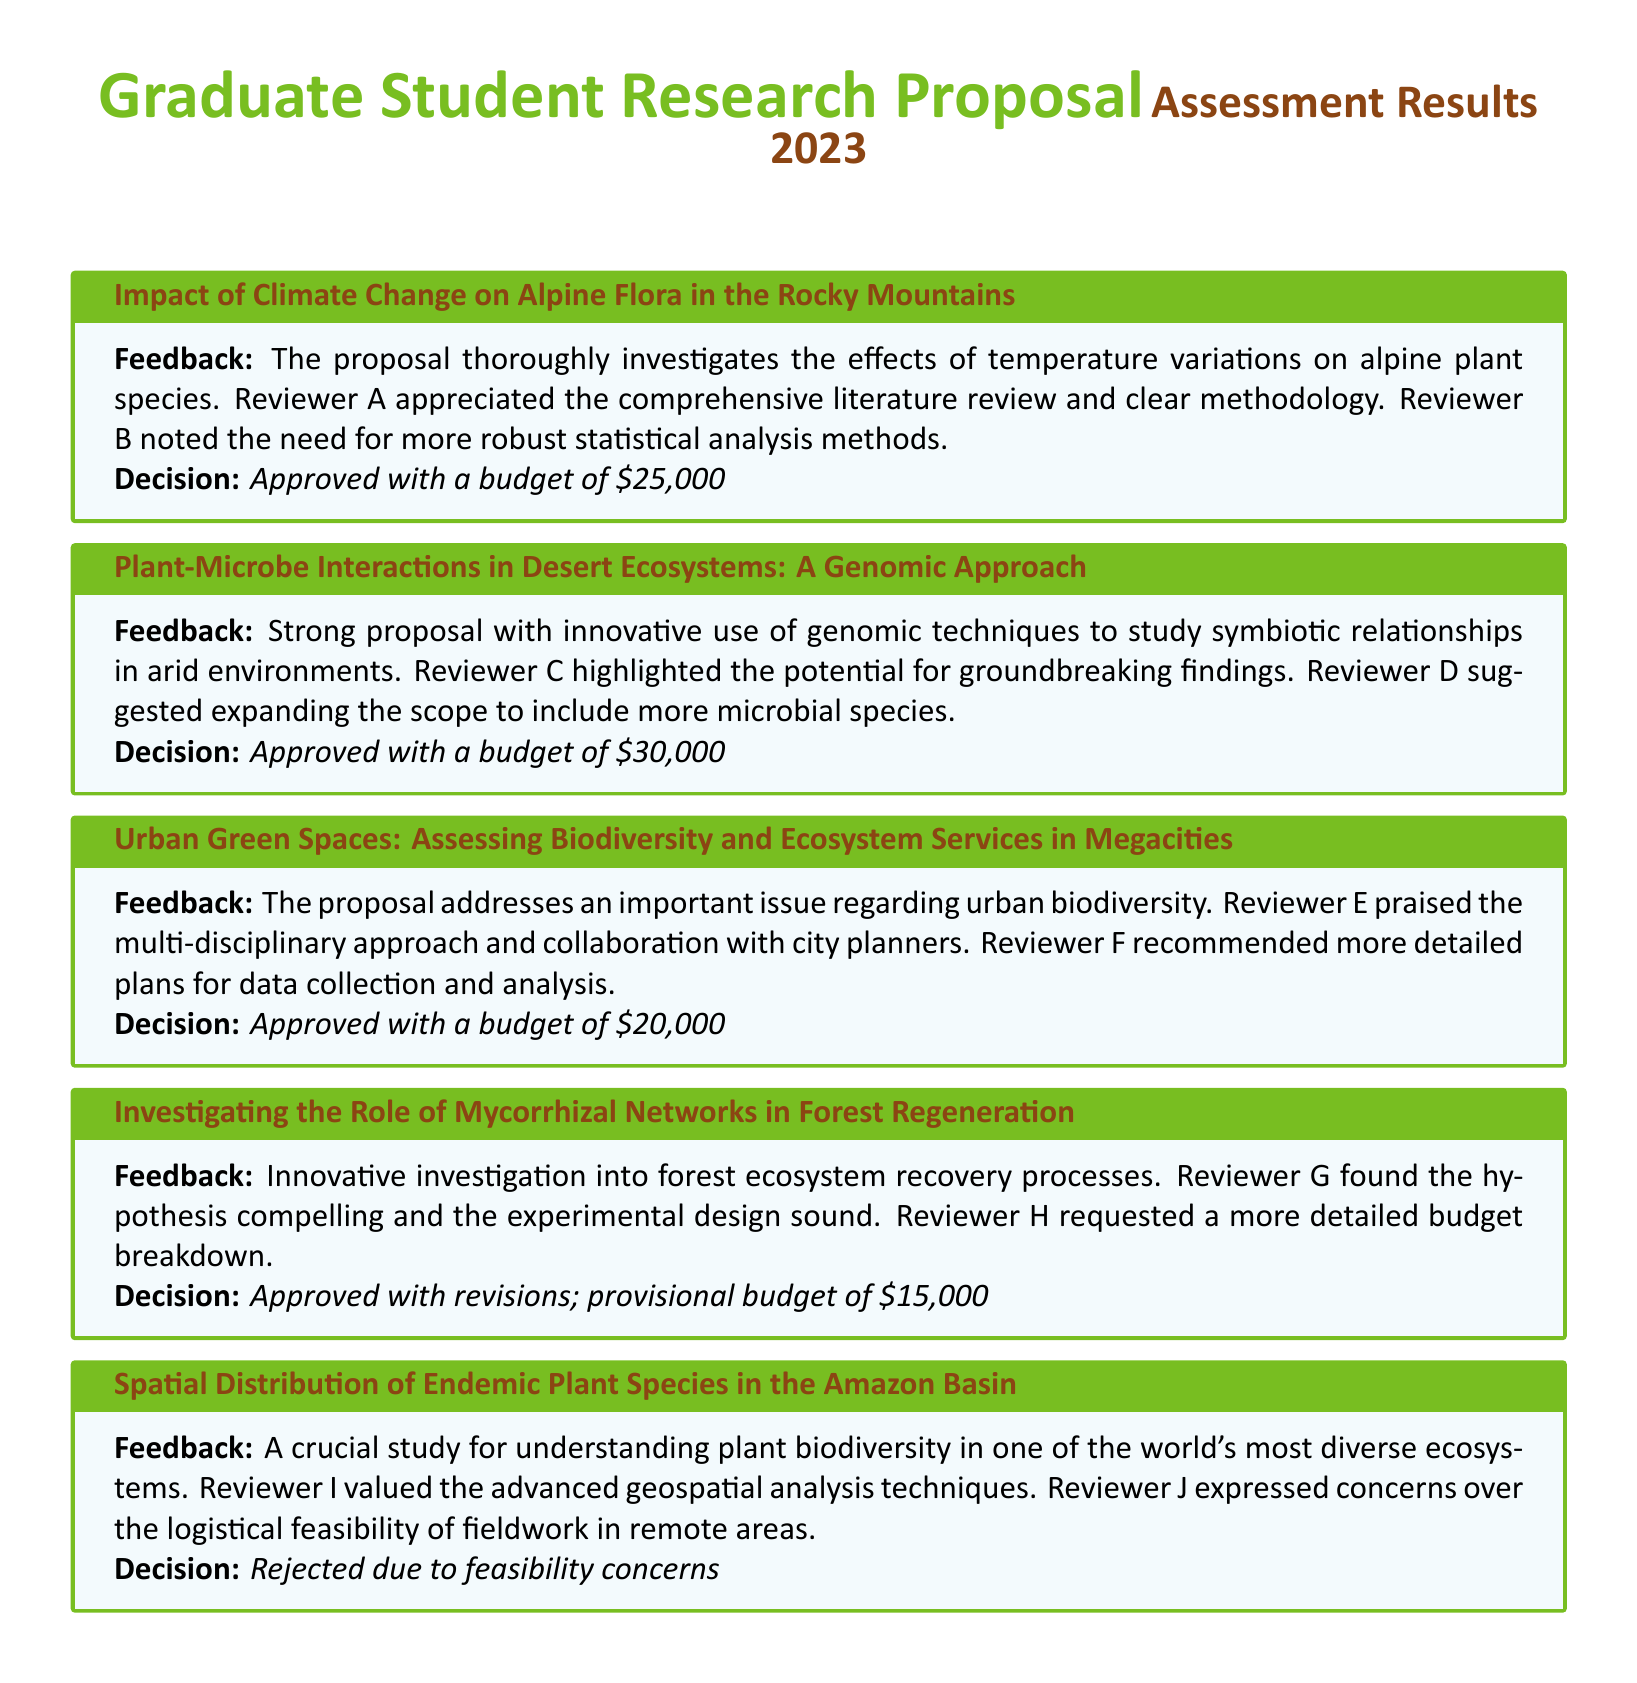What is the title of the proposal regarding urban biodiversity? The title of the proposal is found in the section discussing urban biodiversity issues, titled "Urban Green Spaces: Assessing Biodiversity and Ecosystem Services in Megacities."
Answer: Urban Green Spaces: Assessing Biodiversity and Ecosystem Services in Megacities Who praised the multi-disciplinary approach of the urban green spaces proposal? The person who praised the multi-disciplinary approach is mentioned in the feedback section for the urban green spaces proposal as Reviewer E.
Answer: Reviewer E What is the total approved budget for the proposals? The total approved budget is the sum of all approved budgets: $25,000 + $30,000 + $20,000 + $15,000 = $90,000.
Answer: $90,000 Which proposal was rejected due to feasibility concerns? The proposal that was rejected is titled "Spatial Distribution of Endemic Plant Species in the Amazon Basin."
Answer: Spatial Distribution of Endemic Plant Species in the Amazon Basin What feedback did Reviewer A give on the alpine flora proposal? Reviewer A appreciated the comprehensive literature review and clear methodology in the feedback for the alpine flora proposal.
Answer: Appreciated the comprehensive literature review and clear methodology How many proposals received an approved status? The number of proposals with an approved status can be calculated by counting the relevant sections, which totals to 4 proposals.
Answer: 4 proposals Which review panelist suggested expanding the scope for the genomic approach proposal? The review panelist who suggested expanding the scope is noted as Reviewer D in the feedback for the genomic approach proposal.
Answer: Reviewer D What is the provisional budget for the mycorrhizal networks proposal? The provisional budget mentioned for the mycorrhizal networks proposal is stated in the decision section as $15,000.
Answer: $15,000 